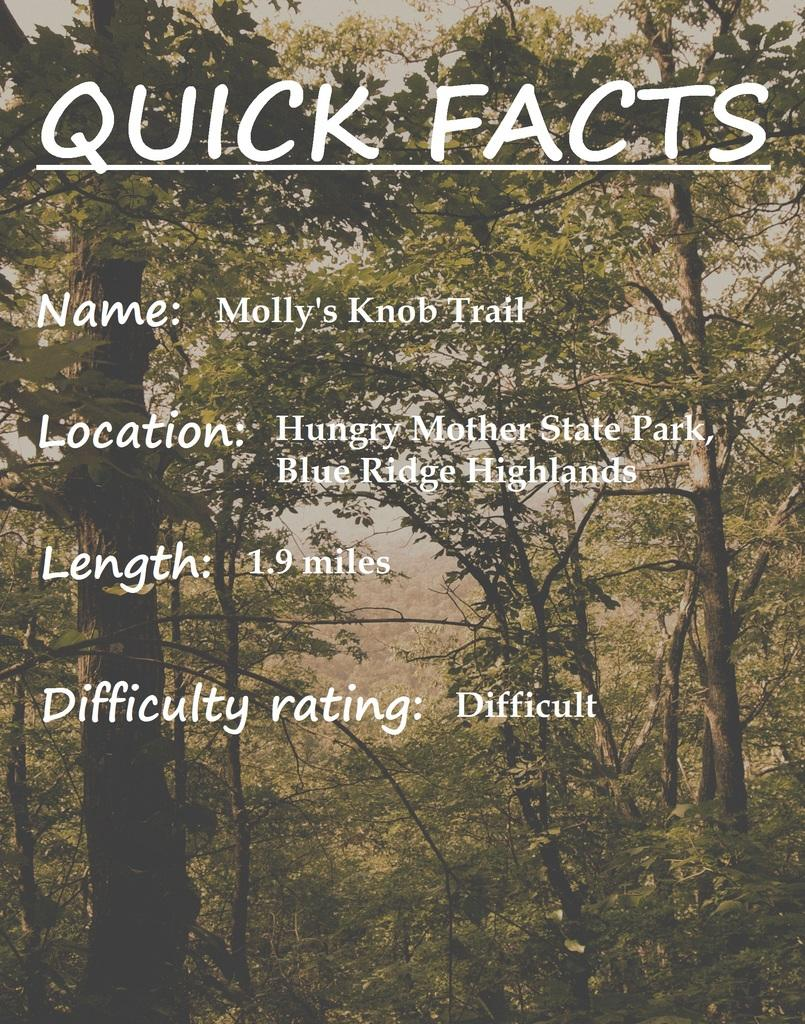Provide a one-sentence caption for the provided image. A picture of a washed out forest with white text describing different quick facts. 